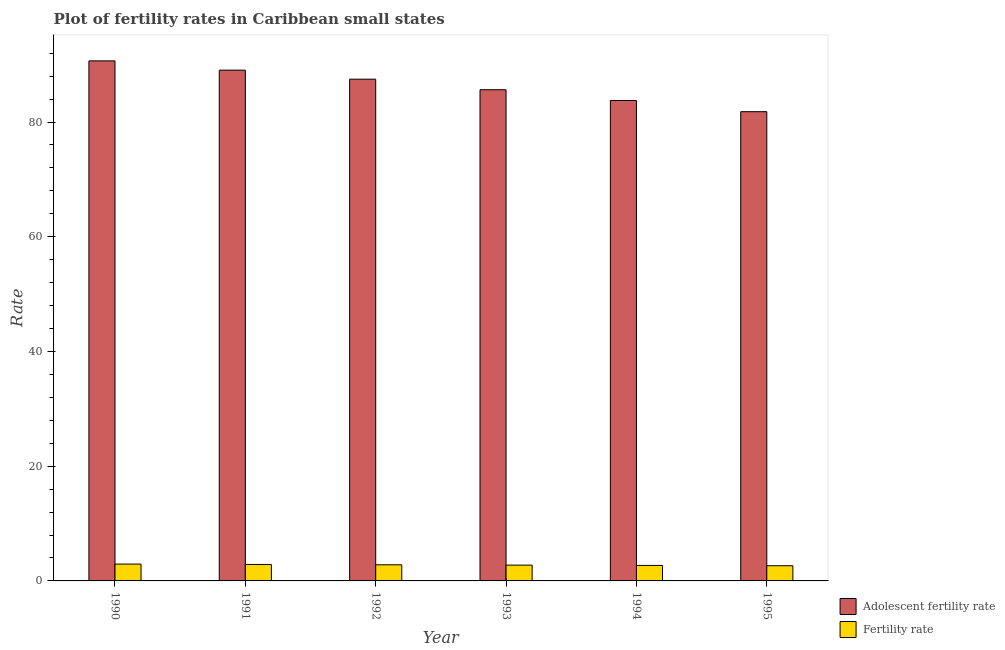How many different coloured bars are there?
Make the answer very short. 2. How many groups of bars are there?
Offer a very short reply. 6. Are the number of bars per tick equal to the number of legend labels?
Give a very brief answer. Yes. How many bars are there on the 4th tick from the left?
Give a very brief answer. 2. How many bars are there on the 1st tick from the right?
Offer a terse response. 2. In how many cases, is the number of bars for a given year not equal to the number of legend labels?
Make the answer very short. 0. What is the fertility rate in 1990?
Offer a terse response. 2.94. Across all years, what is the maximum fertility rate?
Your answer should be very brief. 2.94. Across all years, what is the minimum adolescent fertility rate?
Your response must be concise. 81.81. In which year was the fertility rate maximum?
Provide a succinct answer. 1990. What is the total fertility rate in the graph?
Offer a terse response. 16.72. What is the difference between the adolescent fertility rate in 1994 and that in 1995?
Give a very brief answer. 1.95. What is the difference between the adolescent fertility rate in 1990 and the fertility rate in 1995?
Your response must be concise. 8.86. What is the average adolescent fertility rate per year?
Give a very brief answer. 86.4. In the year 1995, what is the difference between the adolescent fertility rate and fertility rate?
Keep it short and to the point. 0. What is the ratio of the adolescent fertility rate in 1990 to that in 1993?
Provide a short and direct response. 1.06. Is the difference between the adolescent fertility rate in 1990 and 1992 greater than the difference between the fertility rate in 1990 and 1992?
Provide a succinct answer. No. What is the difference between the highest and the second highest adolescent fertility rate?
Ensure brevity in your answer.  1.62. What is the difference between the highest and the lowest fertility rate?
Provide a succinct answer. 0.29. In how many years, is the fertility rate greater than the average fertility rate taken over all years?
Provide a succinct answer. 3. Is the sum of the adolescent fertility rate in 1991 and 1993 greater than the maximum fertility rate across all years?
Make the answer very short. Yes. What does the 1st bar from the left in 1995 represents?
Your answer should be very brief. Adolescent fertility rate. What does the 1st bar from the right in 1994 represents?
Your answer should be very brief. Fertility rate. Are all the bars in the graph horizontal?
Your answer should be compact. No. How many years are there in the graph?
Make the answer very short. 6. Are the values on the major ticks of Y-axis written in scientific E-notation?
Ensure brevity in your answer.  No. Does the graph contain grids?
Offer a terse response. No. Where does the legend appear in the graph?
Your answer should be very brief. Bottom right. How are the legend labels stacked?
Offer a terse response. Vertical. What is the title of the graph?
Your answer should be compact. Plot of fertility rates in Caribbean small states. Does "GDP at market prices" appear as one of the legend labels in the graph?
Keep it short and to the point. No. What is the label or title of the X-axis?
Provide a short and direct response. Year. What is the label or title of the Y-axis?
Offer a very short reply. Rate. What is the Rate in Adolescent fertility rate in 1990?
Offer a terse response. 90.66. What is the Rate in Fertility rate in 1990?
Provide a short and direct response. 2.94. What is the Rate of Adolescent fertility rate in 1991?
Your response must be concise. 89.05. What is the Rate in Fertility rate in 1991?
Provide a succinct answer. 2.87. What is the Rate in Adolescent fertility rate in 1992?
Offer a very short reply. 87.47. What is the Rate in Fertility rate in 1992?
Ensure brevity in your answer.  2.81. What is the Rate of Adolescent fertility rate in 1993?
Ensure brevity in your answer.  85.64. What is the Rate in Fertility rate in 1993?
Your answer should be very brief. 2.75. What is the Rate in Adolescent fertility rate in 1994?
Your answer should be compact. 83.76. What is the Rate of Fertility rate in 1994?
Give a very brief answer. 2.7. What is the Rate in Adolescent fertility rate in 1995?
Your answer should be compact. 81.81. What is the Rate of Fertility rate in 1995?
Provide a succinct answer. 2.65. Across all years, what is the maximum Rate of Adolescent fertility rate?
Make the answer very short. 90.66. Across all years, what is the maximum Rate of Fertility rate?
Offer a terse response. 2.94. Across all years, what is the minimum Rate of Adolescent fertility rate?
Provide a short and direct response. 81.81. Across all years, what is the minimum Rate in Fertility rate?
Your response must be concise. 2.65. What is the total Rate of Adolescent fertility rate in the graph?
Your answer should be compact. 518.39. What is the total Rate of Fertility rate in the graph?
Provide a succinct answer. 16.72. What is the difference between the Rate of Adolescent fertility rate in 1990 and that in 1991?
Your answer should be very brief. 1.62. What is the difference between the Rate of Fertility rate in 1990 and that in 1991?
Your answer should be very brief. 0.06. What is the difference between the Rate of Adolescent fertility rate in 1990 and that in 1992?
Ensure brevity in your answer.  3.19. What is the difference between the Rate of Fertility rate in 1990 and that in 1992?
Your response must be concise. 0.13. What is the difference between the Rate in Adolescent fertility rate in 1990 and that in 1993?
Give a very brief answer. 5.03. What is the difference between the Rate of Fertility rate in 1990 and that in 1993?
Provide a succinct answer. 0.18. What is the difference between the Rate in Adolescent fertility rate in 1990 and that in 1994?
Your answer should be compact. 6.91. What is the difference between the Rate in Fertility rate in 1990 and that in 1994?
Your answer should be very brief. 0.24. What is the difference between the Rate in Adolescent fertility rate in 1990 and that in 1995?
Your answer should be very brief. 8.86. What is the difference between the Rate in Fertility rate in 1990 and that in 1995?
Offer a very short reply. 0.29. What is the difference between the Rate of Adolescent fertility rate in 1991 and that in 1992?
Give a very brief answer. 1.58. What is the difference between the Rate in Fertility rate in 1991 and that in 1992?
Keep it short and to the point. 0.06. What is the difference between the Rate of Adolescent fertility rate in 1991 and that in 1993?
Give a very brief answer. 3.41. What is the difference between the Rate of Fertility rate in 1991 and that in 1993?
Provide a succinct answer. 0.12. What is the difference between the Rate in Adolescent fertility rate in 1991 and that in 1994?
Keep it short and to the point. 5.29. What is the difference between the Rate of Fertility rate in 1991 and that in 1994?
Provide a short and direct response. 0.17. What is the difference between the Rate in Adolescent fertility rate in 1991 and that in 1995?
Make the answer very short. 7.24. What is the difference between the Rate in Fertility rate in 1991 and that in 1995?
Your answer should be compact. 0.22. What is the difference between the Rate of Adolescent fertility rate in 1992 and that in 1993?
Offer a terse response. 1.84. What is the difference between the Rate in Fertility rate in 1992 and that in 1993?
Your answer should be compact. 0.06. What is the difference between the Rate in Adolescent fertility rate in 1992 and that in 1994?
Keep it short and to the point. 3.72. What is the difference between the Rate in Fertility rate in 1992 and that in 1994?
Your answer should be very brief. 0.11. What is the difference between the Rate in Adolescent fertility rate in 1992 and that in 1995?
Make the answer very short. 5.67. What is the difference between the Rate of Fertility rate in 1992 and that in 1995?
Provide a succinct answer. 0.16. What is the difference between the Rate of Adolescent fertility rate in 1993 and that in 1994?
Offer a very short reply. 1.88. What is the difference between the Rate of Fertility rate in 1993 and that in 1994?
Offer a very short reply. 0.05. What is the difference between the Rate in Adolescent fertility rate in 1993 and that in 1995?
Provide a succinct answer. 3.83. What is the difference between the Rate of Fertility rate in 1993 and that in 1995?
Keep it short and to the point. 0.11. What is the difference between the Rate in Adolescent fertility rate in 1994 and that in 1995?
Offer a terse response. 1.95. What is the difference between the Rate of Fertility rate in 1994 and that in 1995?
Provide a succinct answer. 0.05. What is the difference between the Rate of Adolescent fertility rate in 1990 and the Rate of Fertility rate in 1991?
Ensure brevity in your answer.  87.79. What is the difference between the Rate in Adolescent fertility rate in 1990 and the Rate in Fertility rate in 1992?
Offer a terse response. 87.85. What is the difference between the Rate in Adolescent fertility rate in 1990 and the Rate in Fertility rate in 1993?
Keep it short and to the point. 87.91. What is the difference between the Rate in Adolescent fertility rate in 1990 and the Rate in Fertility rate in 1994?
Your response must be concise. 87.96. What is the difference between the Rate of Adolescent fertility rate in 1990 and the Rate of Fertility rate in 1995?
Ensure brevity in your answer.  88.02. What is the difference between the Rate in Adolescent fertility rate in 1991 and the Rate in Fertility rate in 1992?
Give a very brief answer. 86.24. What is the difference between the Rate in Adolescent fertility rate in 1991 and the Rate in Fertility rate in 1993?
Your answer should be compact. 86.29. What is the difference between the Rate of Adolescent fertility rate in 1991 and the Rate of Fertility rate in 1994?
Offer a terse response. 86.35. What is the difference between the Rate in Adolescent fertility rate in 1991 and the Rate in Fertility rate in 1995?
Offer a very short reply. 86.4. What is the difference between the Rate of Adolescent fertility rate in 1992 and the Rate of Fertility rate in 1993?
Keep it short and to the point. 84.72. What is the difference between the Rate in Adolescent fertility rate in 1992 and the Rate in Fertility rate in 1994?
Ensure brevity in your answer.  84.77. What is the difference between the Rate in Adolescent fertility rate in 1992 and the Rate in Fertility rate in 1995?
Make the answer very short. 84.82. What is the difference between the Rate of Adolescent fertility rate in 1993 and the Rate of Fertility rate in 1994?
Offer a very short reply. 82.94. What is the difference between the Rate in Adolescent fertility rate in 1993 and the Rate in Fertility rate in 1995?
Provide a short and direct response. 82.99. What is the difference between the Rate of Adolescent fertility rate in 1994 and the Rate of Fertility rate in 1995?
Make the answer very short. 81.11. What is the average Rate in Adolescent fertility rate per year?
Your answer should be very brief. 86.4. What is the average Rate of Fertility rate per year?
Your response must be concise. 2.79. In the year 1990, what is the difference between the Rate of Adolescent fertility rate and Rate of Fertility rate?
Provide a succinct answer. 87.73. In the year 1991, what is the difference between the Rate of Adolescent fertility rate and Rate of Fertility rate?
Your response must be concise. 86.18. In the year 1992, what is the difference between the Rate of Adolescent fertility rate and Rate of Fertility rate?
Keep it short and to the point. 84.66. In the year 1993, what is the difference between the Rate of Adolescent fertility rate and Rate of Fertility rate?
Make the answer very short. 82.88. In the year 1994, what is the difference between the Rate in Adolescent fertility rate and Rate in Fertility rate?
Provide a succinct answer. 81.06. In the year 1995, what is the difference between the Rate of Adolescent fertility rate and Rate of Fertility rate?
Keep it short and to the point. 79.16. What is the ratio of the Rate in Adolescent fertility rate in 1990 to that in 1991?
Your answer should be compact. 1.02. What is the ratio of the Rate in Fertility rate in 1990 to that in 1991?
Provide a succinct answer. 1.02. What is the ratio of the Rate of Adolescent fertility rate in 1990 to that in 1992?
Offer a terse response. 1.04. What is the ratio of the Rate in Fertility rate in 1990 to that in 1992?
Make the answer very short. 1.04. What is the ratio of the Rate of Adolescent fertility rate in 1990 to that in 1993?
Ensure brevity in your answer.  1.06. What is the ratio of the Rate in Fertility rate in 1990 to that in 1993?
Provide a short and direct response. 1.07. What is the ratio of the Rate of Adolescent fertility rate in 1990 to that in 1994?
Your answer should be very brief. 1.08. What is the ratio of the Rate in Fertility rate in 1990 to that in 1994?
Your answer should be compact. 1.09. What is the ratio of the Rate in Adolescent fertility rate in 1990 to that in 1995?
Offer a terse response. 1.11. What is the ratio of the Rate in Fertility rate in 1990 to that in 1995?
Ensure brevity in your answer.  1.11. What is the ratio of the Rate in Fertility rate in 1991 to that in 1992?
Your response must be concise. 1.02. What is the ratio of the Rate in Adolescent fertility rate in 1991 to that in 1993?
Ensure brevity in your answer.  1.04. What is the ratio of the Rate in Fertility rate in 1991 to that in 1993?
Offer a terse response. 1.04. What is the ratio of the Rate of Adolescent fertility rate in 1991 to that in 1994?
Your answer should be compact. 1.06. What is the ratio of the Rate in Fertility rate in 1991 to that in 1994?
Provide a succinct answer. 1.06. What is the ratio of the Rate in Adolescent fertility rate in 1991 to that in 1995?
Your answer should be compact. 1.09. What is the ratio of the Rate of Fertility rate in 1991 to that in 1995?
Give a very brief answer. 1.08. What is the ratio of the Rate of Adolescent fertility rate in 1992 to that in 1993?
Make the answer very short. 1.02. What is the ratio of the Rate of Fertility rate in 1992 to that in 1993?
Your answer should be very brief. 1.02. What is the ratio of the Rate in Adolescent fertility rate in 1992 to that in 1994?
Offer a very short reply. 1.04. What is the ratio of the Rate of Fertility rate in 1992 to that in 1994?
Your answer should be very brief. 1.04. What is the ratio of the Rate of Adolescent fertility rate in 1992 to that in 1995?
Give a very brief answer. 1.07. What is the ratio of the Rate of Fertility rate in 1992 to that in 1995?
Offer a terse response. 1.06. What is the ratio of the Rate in Adolescent fertility rate in 1993 to that in 1994?
Provide a short and direct response. 1.02. What is the ratio of the Rate of Fertility rate in 1993 to that in 1994?
Your response must be concise. 1.02. What is the ratio of the Rate in Adolescent fertility rate in 1993 to that in 1995?
Provide a short and direct response. 1.05. What is the ratio of the Rate of Fertility rate in 1993 to that in 1995?
Provide a short and direct response. 1.04. What is the ratio of the Rate in Adolescent fertility rate in 1994 to that in 1995?
Make the answer very short. 1.02. What is the ratio of the Rate in Fertility rate in 1994 to that in 1995?
Offer a terse response. 1.02. What is the difference between the highest and the second highest Rate of Adolescent fertility rate?
Offer a very short reply. 1.62. What is the difference between the highest and the second highest Rate in Fertility rate?
Your answer should be compact. 0.06. What is the difference between the highest and the lowest Rate of Adolescent fertility rate?
Your answer should be very brief. 8.86. What is the difference between the highest and the lowest Rate of Fertility rate?
Your answer should be compact. 0.29. 